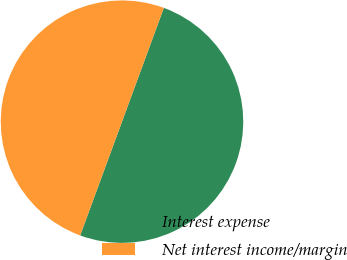<chart> <loc_0><loc_0><loc_500><loc_500><pie_chart><fcel>Interest expense<fcel>Net interest income/margin<nl><fcel>50.0%<fcel>50.0%<nl></chart> 